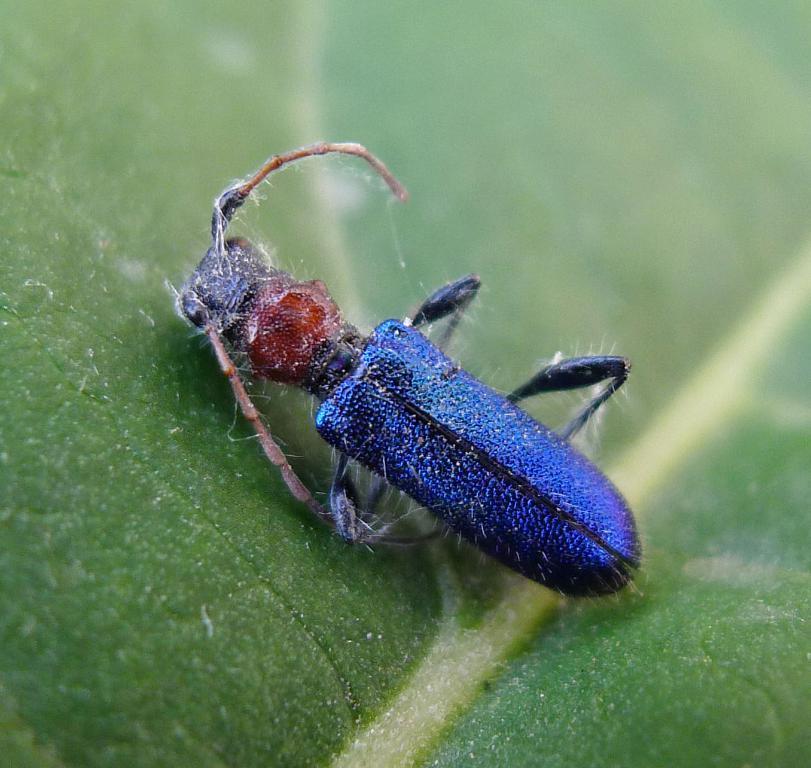Please provide a concise description of this image. In this image there is an insect on a leaf. 